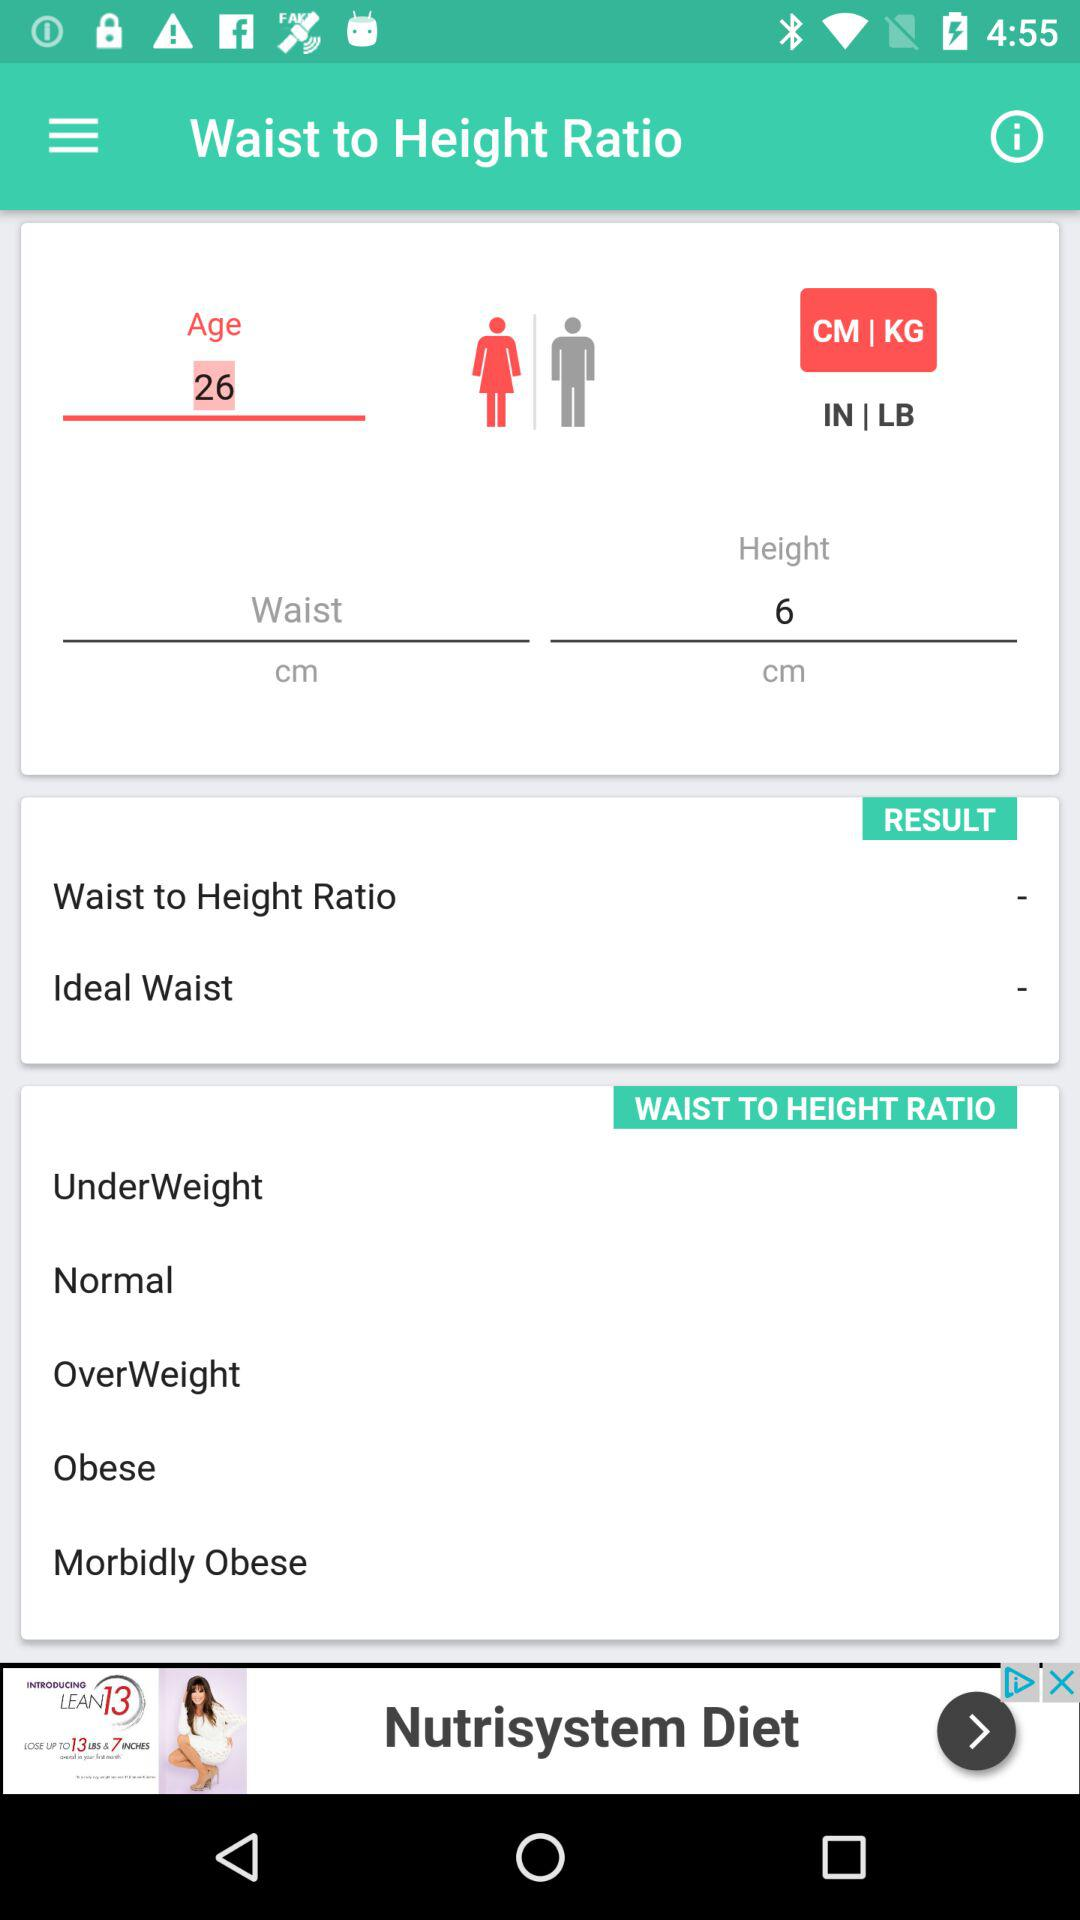What is the age? The age is 26. 